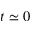Convert formula to latex. <formula><loc_0><loc_0><loc_500><loc_500>t \simeq 0</formula> 